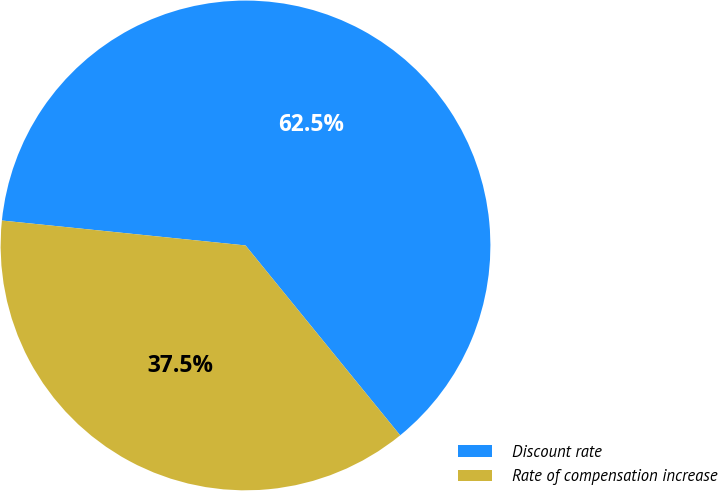<chart> <loc_0><loc_0><loc_500><loc_500><pie_chart><fcel>Discount rate<fcel>Rate of compensation increase<nl><fcel>62.5%<fcel>37.5%<nl></chart> 